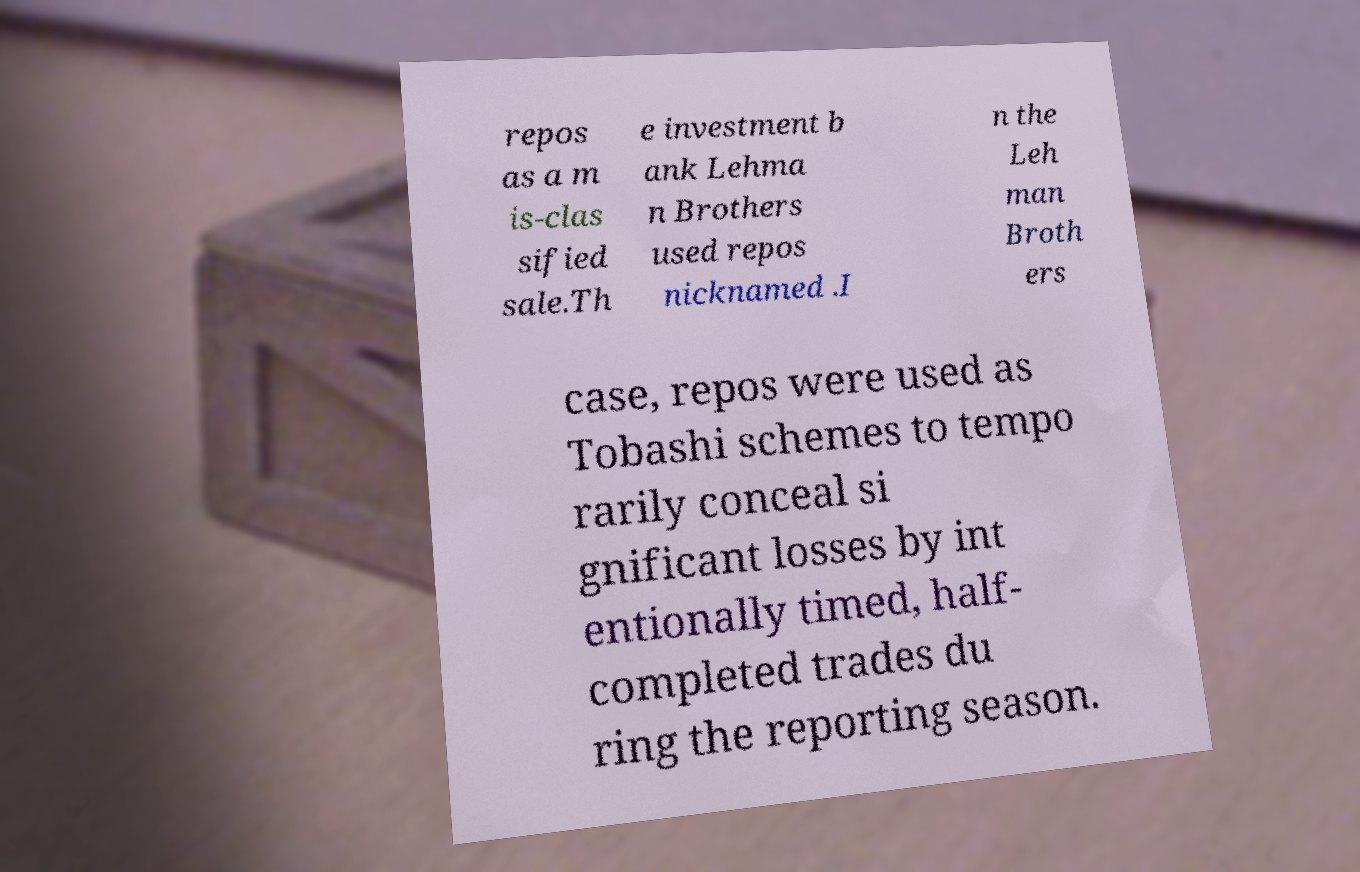There's text embedded in this image that I need extracted. Can you transcribe it verbatim? repos as a m is-clas sified sale.Th e investment b ank Lehma n Brothers used repos nicknamed .I n the Leh man Broth ers case, repos were used as Tobashi schemes to tempo rarily conceal si gnificant losses by int entionally timed, half- completed trades du ring the reporting season. 